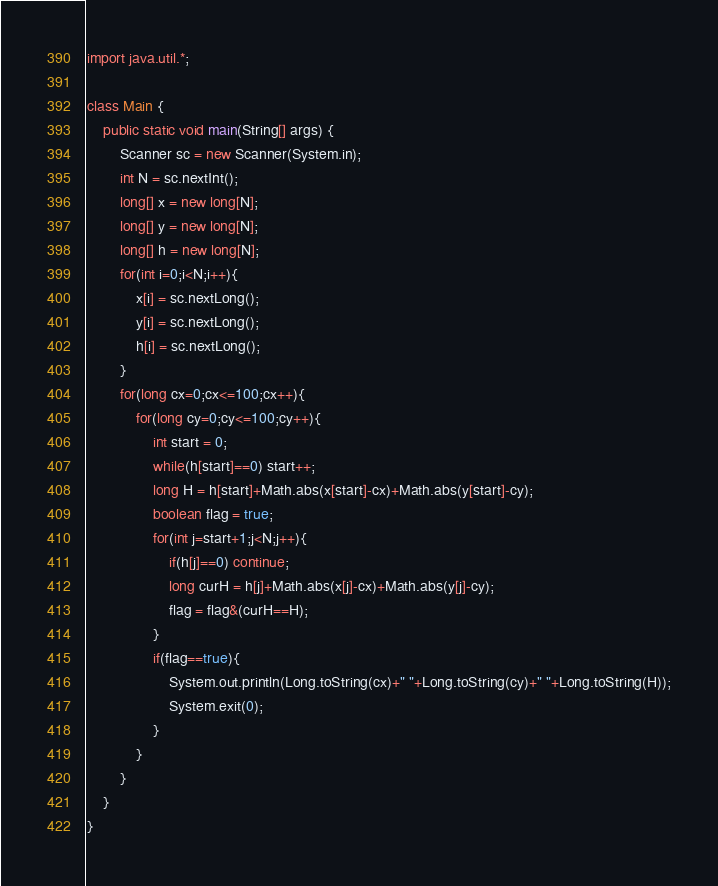<code> <loc_0><loc_0><loc_500><loc_500><_Java_>import java.util.*;

class Main {
    public static void main(String[] args) {
        Scanner sc = new Scanner(System.in);
        int N = sc.nextInt();
        long[] x = new long[N];
        long[] y = new long[N];
        long[] h = new long[N];
        for(int i=0;i<N;i++){
            x[i] = sc.nextLong();
            y[i] = sc.nextLong();
            h[i] = sc.nextLong();
        }
        for(long cx=0;cx<=100;cx++){
            for(long cy=0;cy<=100;cy++){
                int start = 0;
                while(h[start]==0) start++;
                long H = h[start]+Math.abs(x[start]-cx)+Math.abs(y[start]-cy);
                boolean flag = true;
                for(int j=start+1;j<N;j++){
                    if(h[j]==0) continue;
                    long curH = h[j]+Math.abs(x[j]-cx)+Math.abs(y[j]-cy);
                    flag = flag&(curH==H);
                }
                if(flag==true){
                    System.out.println(Long.toString(cx)+" "+Long.toString(cy)+" "+Long.toString(H));
                    System.exit(0);
                }
            }
        }
    }
}
</code> 